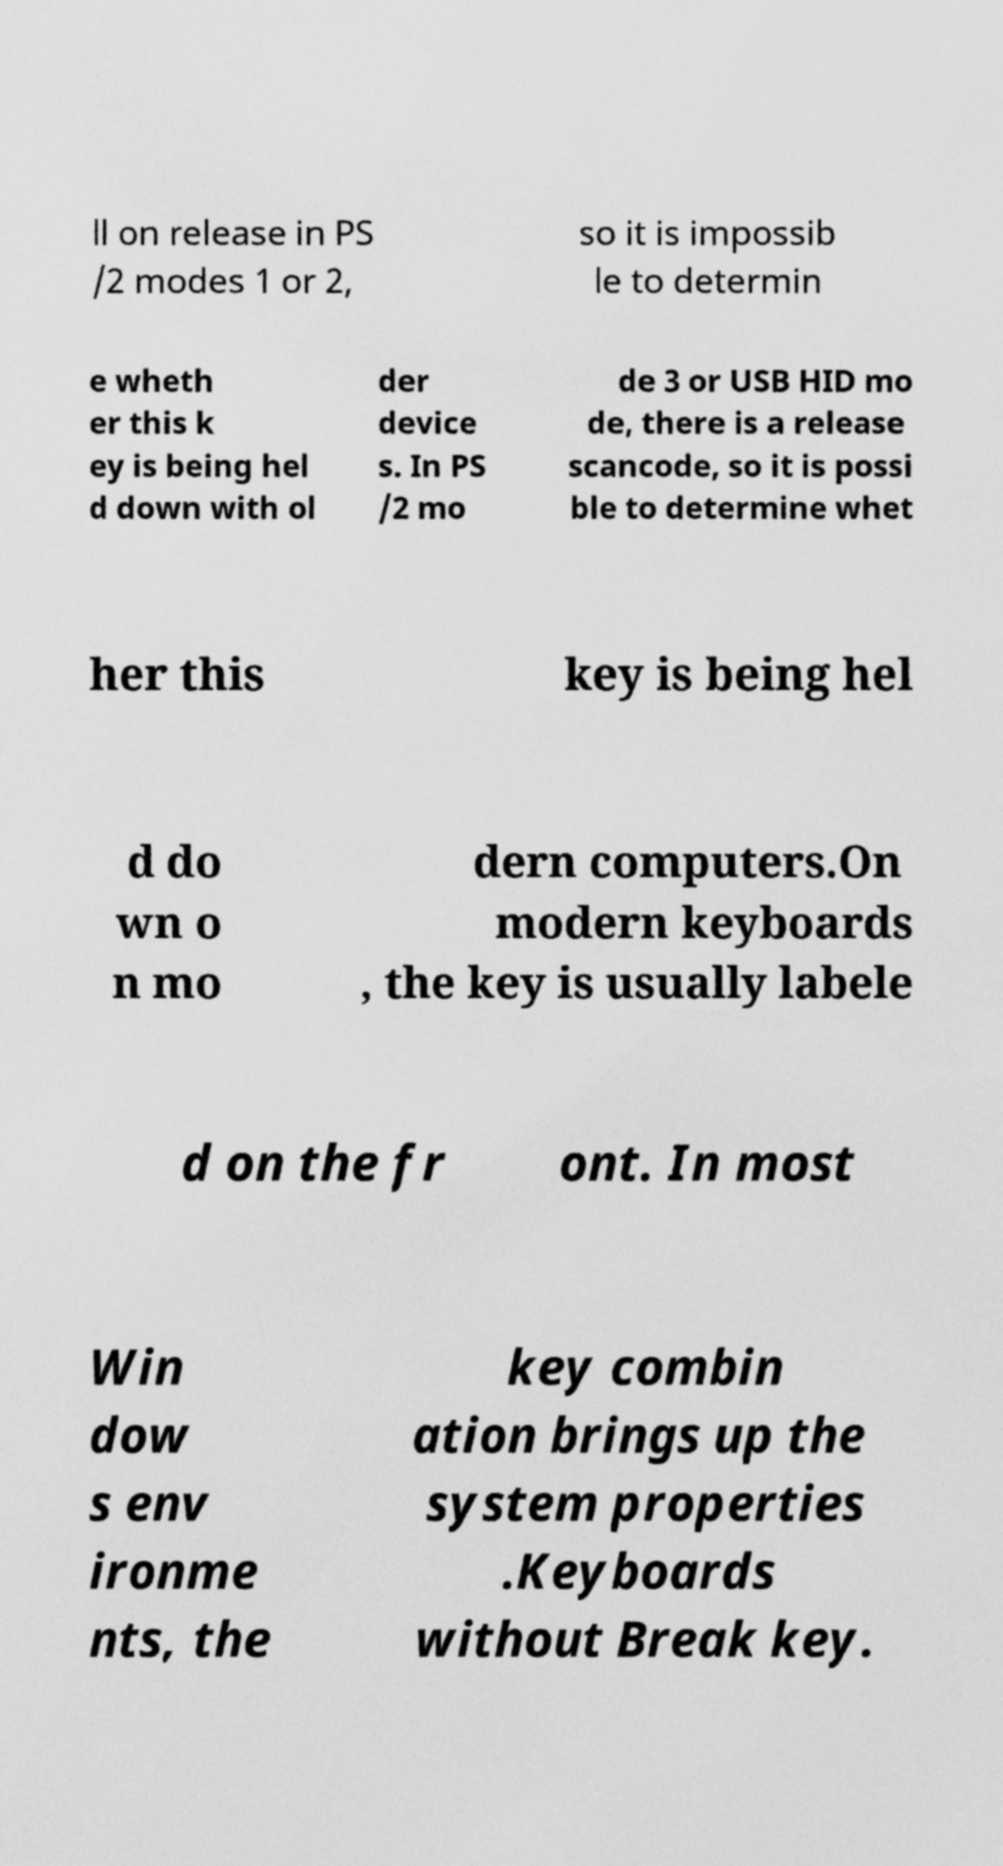Can you read and provide the text displayed in the image?This photo seems to have some interesting text. Can you extract and type it out for me? ll on release in PS /2 modes 1 or 2, so it is impossib le to determin e wheth er this k ey is being hel d down with ol der device s. In PS /2 mo de 3 or USB HID mo de, there is a release scancode, so it is possi ble to determine whet her this key is being hel d do wn o n mo dern computers.On modern keyboards , the key is usually labele d on the fr ont. In most Win dow s env ironme nts, the key combin ation brings up the system properties .Keyboards without Break key. 